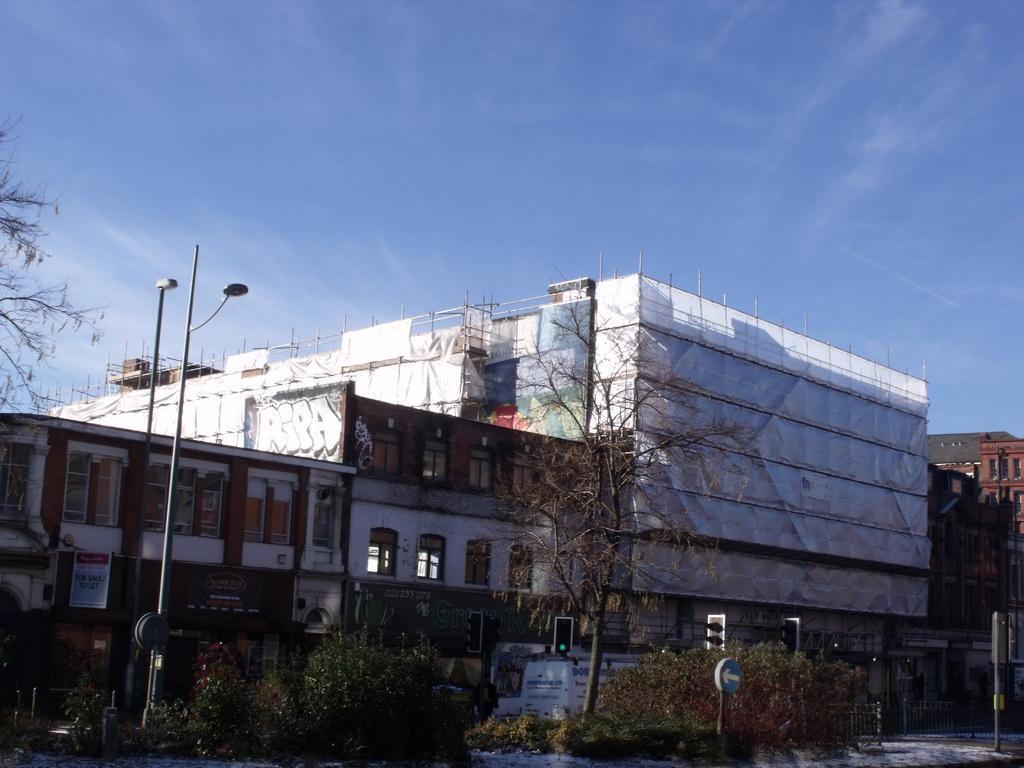In one or two sentences, can you explain what this image depicts? In the picture I can see plants, light poles, traffic signal poles, caution boards, buildings, trees and the blue color sky with clouds in the background. 